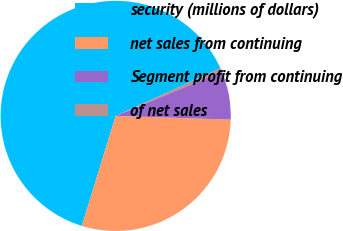Convert chart to OTSL. <chart><loc_0><loc_0><loc_500><loc_500><pie_chart><fcel>security (millions of dollars)<fcel>net sales from continuing<fcel>Segment profit from continuing<fcel>of net sales<nl><fcel>63.45%<fcel>29.24%<fcel>6.8%<fcel>0.51%<nl></chart> 